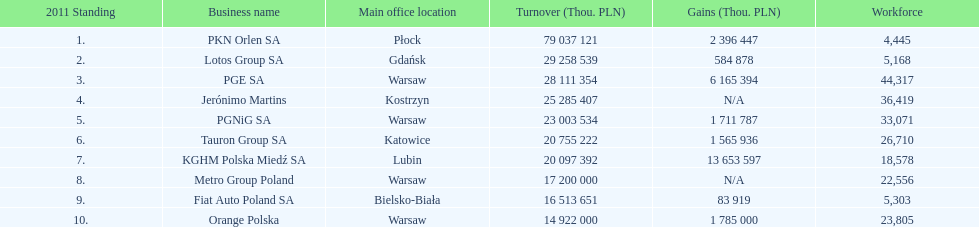What company has the top number of employees? PGE SA. 